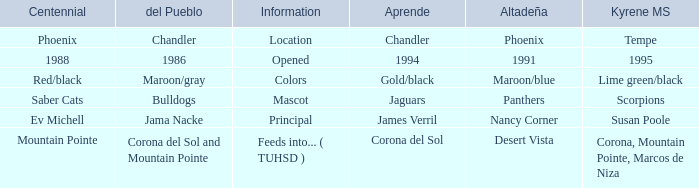Which Altadeña has a Aprende of jaguars? Panthers. 